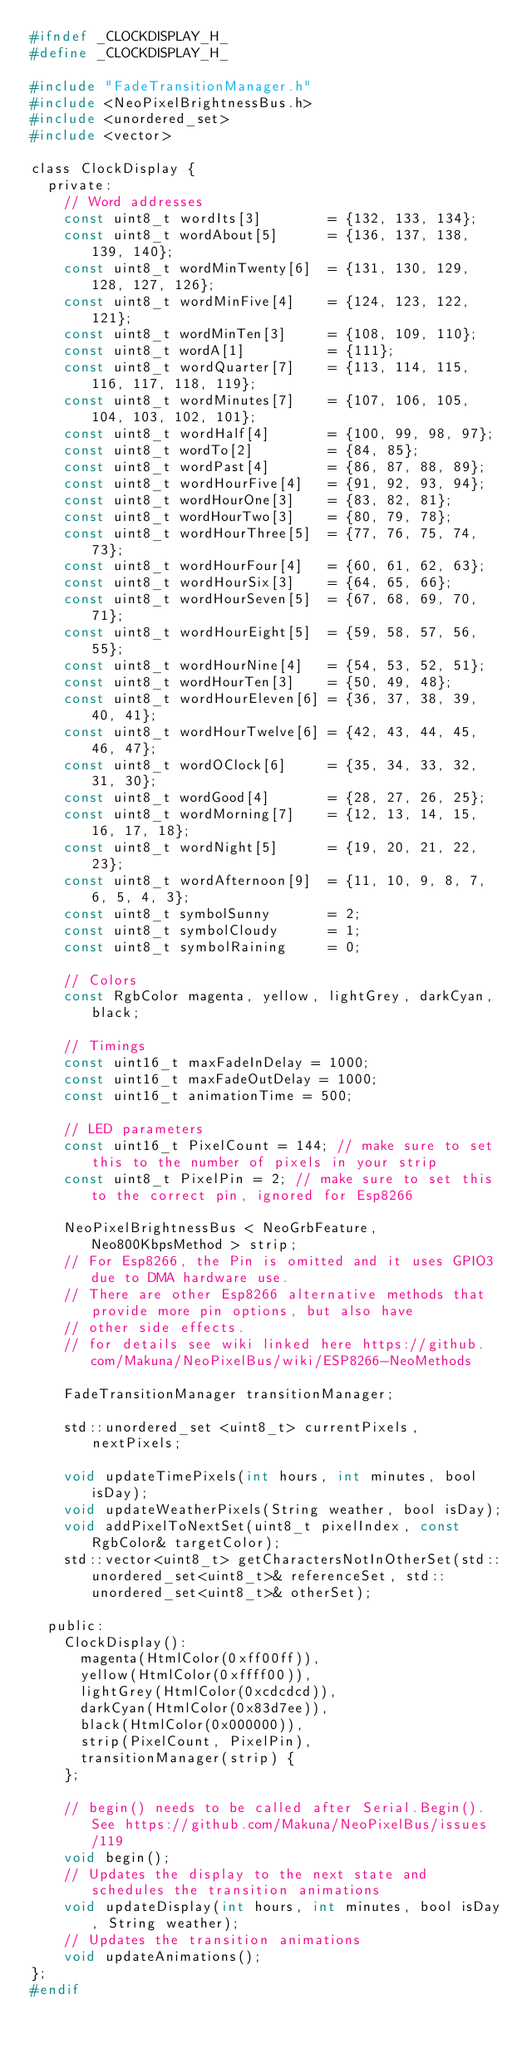<code> <loc_0><loc_0><loc_500><loc_500><_C_>#ifndef _CLOCKDISPLAY_H_
#define _CLOCKDISPLAY_H_

#include "FadeTransitionManager.h"
#include <NeoPixelBrightnessBus.h>
#include <unordered_set>
#include <vector>

class ClockDisplay {
  private:
    // Word addresses
    const uint8_t wordIts[3]        = {132, 133, 134};
    const uint8_t wordAbout[5]      = {136, 137, 138, 139, 140};
    const uint8_t wordMinTwenty[6]  = {131, 130, 129, 128, 127, 126};
    const uint8_t wordMinFive[4]    = {124, 123, 122, 121};
    const uint8_t wordMinTen[3]     = {108, 109, 110};
    const uint8_t wordA[1]          = {111};
    const uint8_t wordQuarter[7]    = {113, 114, 115, 116, 117, 118, 119};
    const uint8_t wordMinutes[7]    = {107, 106, 105, 104, 103, 102, 101};
    const uint8_t wordHalf[4]       = {100, 99, 98, 97};
    const uint8_t wordTo[2]         = {84, 85};
    const uint8_t wordPast[4]       = {86, 87, 88, 89};
    const uint8_t wordHourFive[4]   = {91, 92, 93, 94};
    const uint8_t wordHourOne[3]    = {83, 82, 81};
    const uint8_t wordHourTwo[3]    = {80, 79, 78};
    const uint8_t wordHourThree[5]  = {77, 76, 75, 74, 73};
    const uint8_t wordHourFour[4]   = {60, 61, 62, 63};
    const uint8_t wordHourSix[3]    = {64, 65, 66};
    const uint8_t wordHourSeven[5]  = {67, 68, 69, 70, 71};
    const uint8_t wordHourEight[5]  = {59, 58, 57, 56, 55};
    const uint8_t wordHourNine[4]   = {54, 53, 52, 51};
    const uint8_t wordHourTen[3]    = {50, 49, 48};
    const uint8_t wordHourEleven[6] = {36, 37, 38, 39, 40, 41};
    const uint8_t wordHourTwelve[6] = {42, 43, 44, 45, 46, 47};
    const uint8_t wordOClock[6]     = {35, 34, 33, 32, 31, 30};
    const uint8_t wordGood[4]       = {28, 27, 26, 25};
    const uint8_t wordMorning[7]    = {12, 13, 14, 15, 16, 17, 18};
    const uint8_t wordNight[5]      = {19, 20, 21, 22, 23};
    const uint8_t wordAfternoon[9]  = {11, 10, 9, 8, 7, 6, 5, 4, 3};
    const uint8_t symbolSunny       = 2;
    const uint8_t symbolCloudy      = 1;
    const uint8_t symbolRaining     = 0;

    // Colors
    const RgbColor magenta, yellow, lightGrey, darkCyan, black;

    // Timings
    const uint16_t maxFadeInDelay = 1000;
    const uint16_t maxFadeOutDelay = 1000;
    const uint16_t animationTime = 500;

    // LED parameters
    const uint16_t PixelCount = 144; // make sure to set this to the number of pixels in your strip
    const uint8_t PixelPin = 2; // make sure to set this to the correct pin, ignored for Esp8266

    NeoPixelBrightnessBus < NeoGrbFeature, Neo800KbpsMethod > strip;
    // For Esp8266, the Pin is omitted and it uses GPIO3 due to DMA hardware use.  
    // There are other Esp8266 alternative methods that provide more pin options, but also have
    // other side effects.
    // for details see wiki linked here https://github.com/Makuna/NeoPixelBus/wiki/ESP8266-NeoMethods

    FadeTransitionManager transitionManager;

    std::unordered_set <uint8_t> currentPixels, nextPixels;

    void updateTimePixels(int hours, int minutes, bool isDay);
    void updateWeatherPixels(String weather, bool isDay);
    void addPixelToNextSet(uint8_t pixelIndex, const RgbColor& targetColor);
    std::vector<uint8_t> getCharactersNotInOtherSet(std::unordered_set<uint8_t>& referenceSet, std::unordered_set<uint8_t>& otherSet);

  public:
    ClockDisplay():
      magenta(HtmlColor(0xff00ff)),
      yellow(HtmlColor(0xffff00)),
      lightGrey(HtmlColor(0xcdcdcd)),
      darkCyan(HtmlColor(0x83d7ee)),
      black(HtmlColor(0x000000)),
      strip(PixelCount, PixelPin),
      transitionManager(strip) {
    };

    // begin() needs to be called after Serial.Begin(). See https://github.com/Makuna/NeoPixelBus/issues/119
    void begin();
    // Updates the display to the next state and schedules the transition animations
    void updateDisplay(int hours, int minutes, bool isDay, String weather);
    // Updates the transition animations
    void updateAnimations();
};
#endif
</code> 